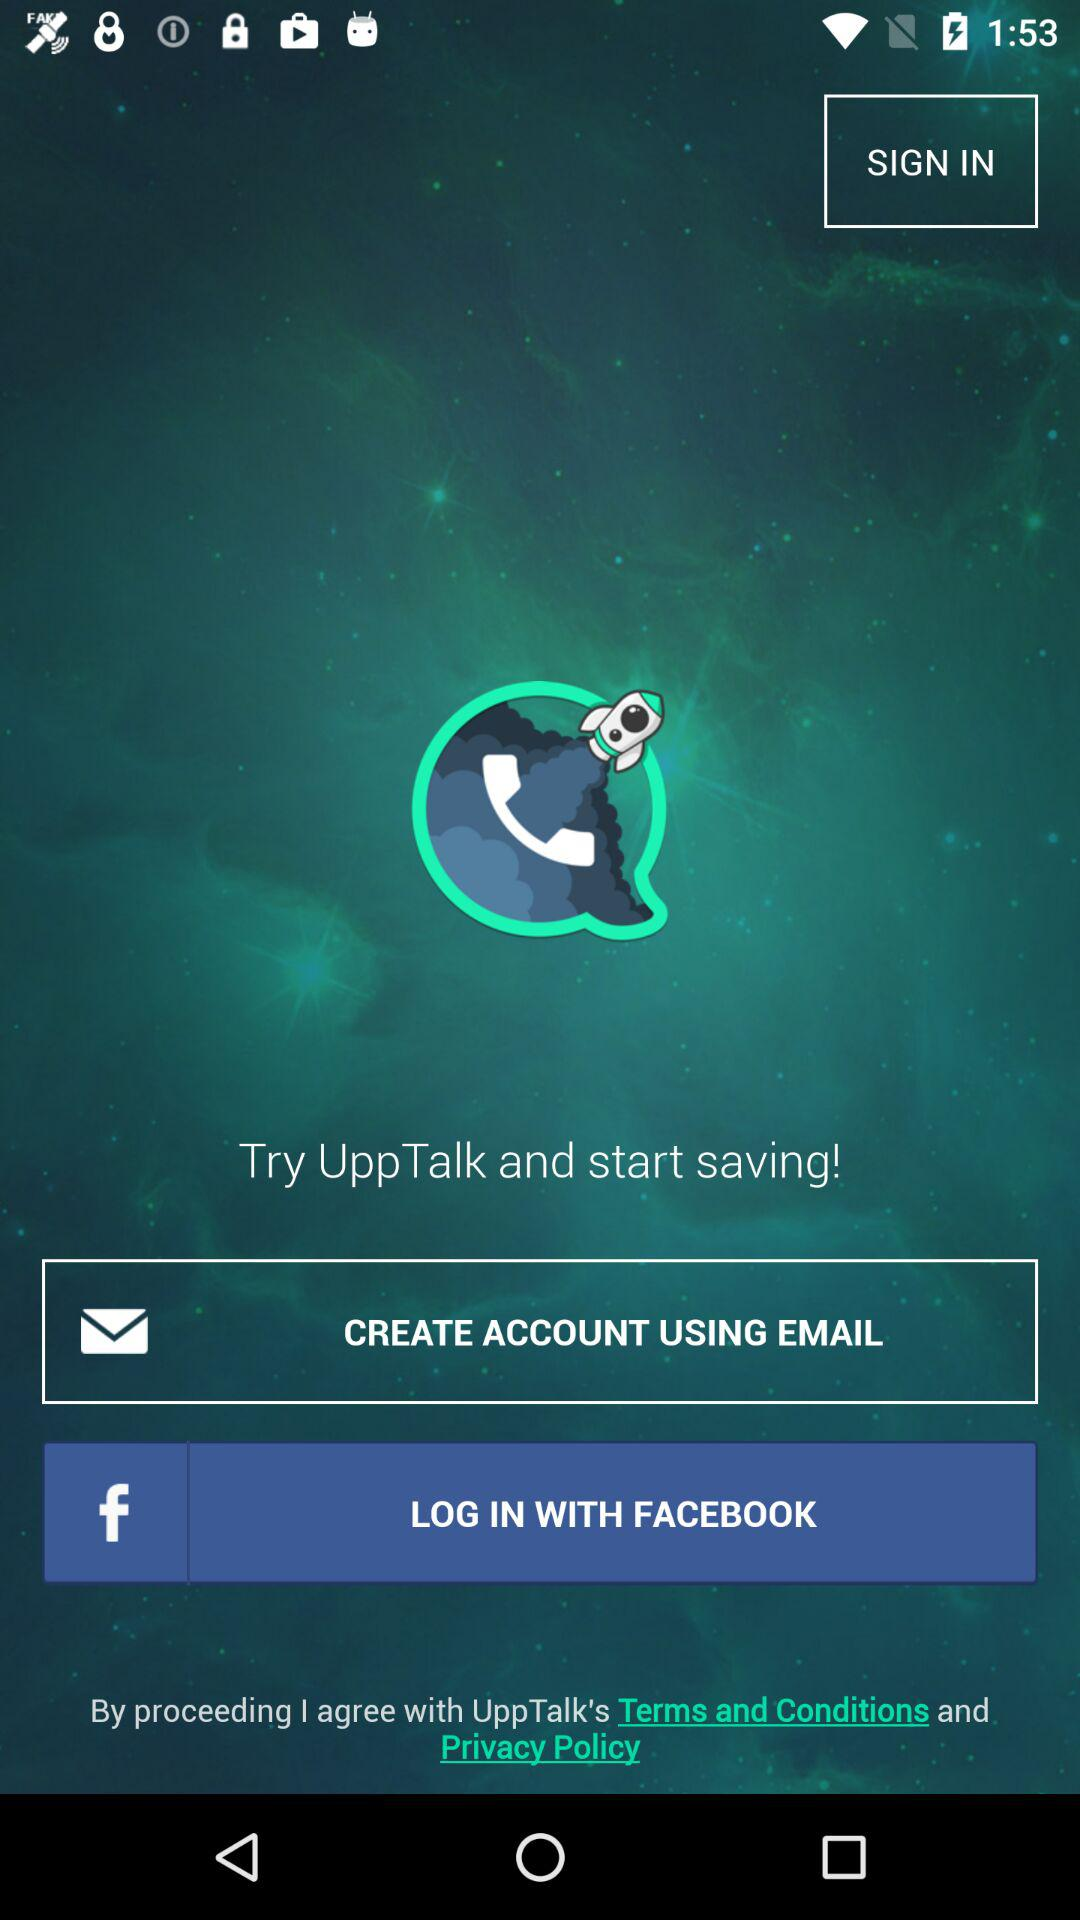How can we create an account? You can create an account by using your email. 